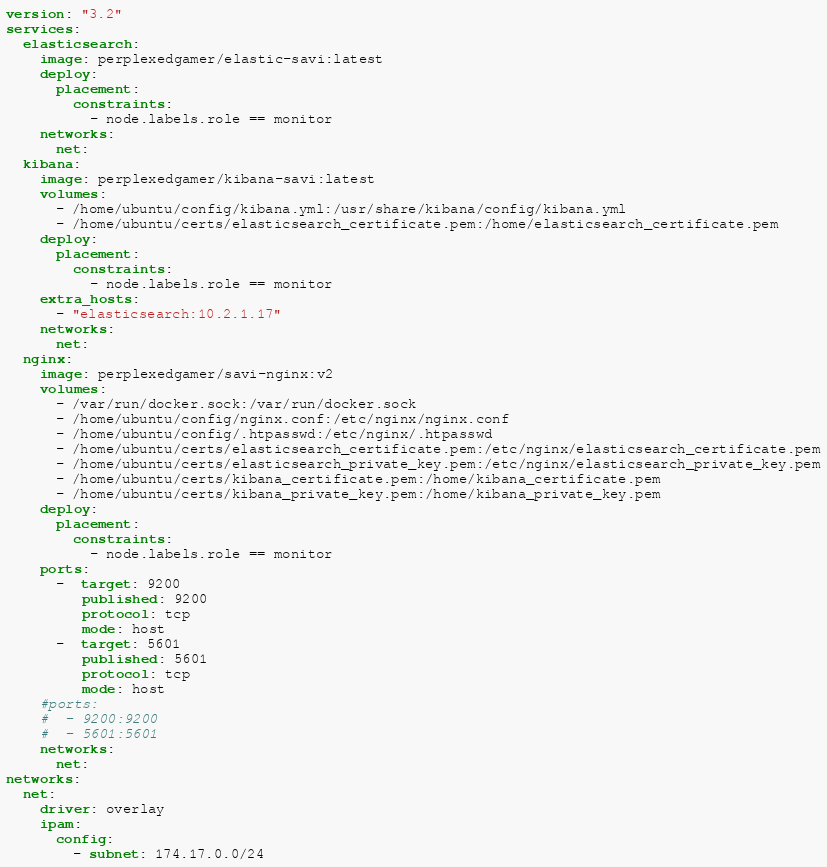<code> <loc_0><loc_0><loc_500><loc_500><_YAML_>version: "3.2"
services:
  elasticsearch:
    image: perplexedgamer/elastic-savi:latest
    deploy:
      placement:
        constraints:
          - node.labels.role == monitor
    networks:
      net:
  kibana:
    image: perplexedgamer/kibana-savi:latest
    volumes:
      - /home/ubuntu/config/kibana.yml:/usr/share/kibana/config/kibana.yml
      - /home/ubuntu/certs/elasticsearch_certificate.pem:/home/elasticsearch_certificate.pem
    deploy:
      placement:
        constraints:
          - node.labels.role == monitor
    extra_hosts: 
      - "elasticsearch:10.2.1.17"
    networks:
      net:
  nginx:
    image: perplexedgamer/savi-nginx:v2
    volumes:
      - /var/run/docker.sock:/var/run/docker.sock
      - /home/ubuntu/config/nginx.conf:/etc/nginx/nginx.conf
      - /home/ubuntu/config/.htpasswd:/etc/nginx/.htpasswd
      - /home/ubuntu/certs/elasticsearch_certificate.pem:/etc/nginx/elasticsearch_certificate.pem
      - /home/ubuntu/certs/elasticsearch_private_key.pem:/etc/nginx/elasticsearch_private_key.pem
      - /home/ubuntu/certs/kibana_certificate.pem:/home/kibana_certificate.pem
      - /home/ubuntu/certs/kibana_private_key.pem:/home/kibana_private_key.pem
    deploy:
      placement:
        constraints:
          - node.labels.role == monitor
    ports:
      -  target: 9200 
         published: 9200
         protocol: tcp
         mode: host   
      -  target: 5601 
         published: 5601
         protocol: tcp
         mode: host   
    #ports:
    #  - 9200:9200
    #  - 5601:5601
    networks:
      net:
networks:
  net:
    driver: overlay 
    ipam:
      config:
        - subnet: 174.17.0.0/24
</code> 